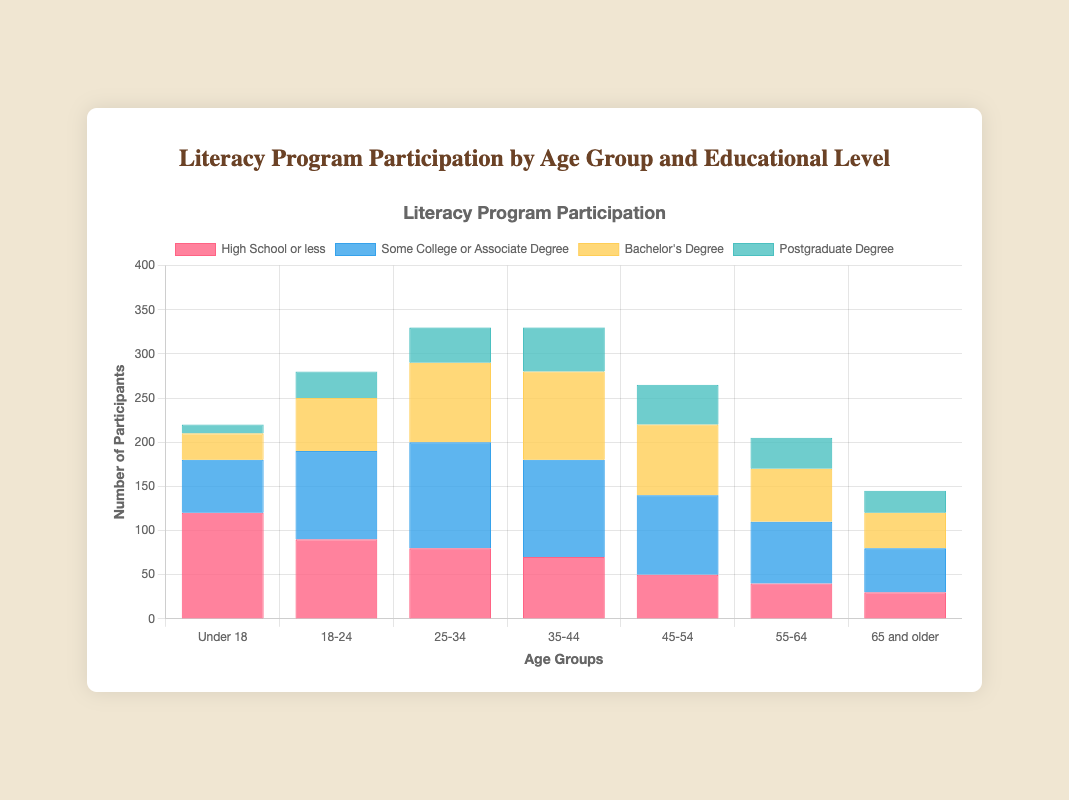What is the age group with the highest number of participants with a Bachelor's Degree? To find the age group with the highest number of participants with a Bachelor's Degree, look at the height of the bar segments representing Bachelor's Degree participants for each age group. The highest bar segment for Bachelor's Degree is for the age group 35-44.
Answer: 35-44 Which educational level has the highest participation in the age group 55-64? For the age group 55-64, compare the heights of the bars for each educational level. The highest bar segment corresponds to "Some College or Associate Degree."
Answer: Some College or Associate Degree What is the total number of participants under the age of 18? Sum the heights of all the bars for each educational level under the "Under 18" category. The values are 120 (High School or less) + 60 (Some College or Associate Degree) + 30 (Bachelor's Degree) + 10 (Postgraduate Degree), resulting in 220 total participants.
Answer: 220 Which age group has the smallest combined participation across all educational levels? Sum the heights of all the bar segments for each age group. The age group "65 and older" has the smallest combined participation: 30 (High School or less) + 50 (Some College or Associate Degree) + 40 (Bachelor's Degree) + 25 (Postgraduate Degree) = 145 participants.
Answer: 65 and older How many more participants in the age group 25-34 have some College or Associate Degree compared to those with Postgraduate Degree? Find the difference between the number of participants in the age group 25-34 with "Some College or Associate Degree" (120) and those with "Postgraduate Degree" (40). 120 - 40 = 80 more participants have some College or Associate Degree.
Answer: 80 What is the average number of participants aged 45-54 across all educational levels? Sum the number of participants aged 45-54 for each educational level and divide by the number of levels. (50 + 90 + 80 + 45) / 4 = 265 / 4 = 66.25 participants on average.
Answer: 66.25 Which educational level has higher participation in the age group 18-24: "High School or less" or "Bachelor's Degree"? Look at the heights of the bar segments for "High School or less" (90) and "Bachelor's Degree" (60) in the age group 18-24. The "High School or less" bar is higher.
Answer: High School or less What is the combined number of participants with a Bachelor's Degree and Postgraduate Degree in the age group 35-44? Add the number of participants with a Bachelor's Degree (100) to the number of participants with a Postgraduate Degree (50) in the age group 35-44. 100 + 50 = 150 participants.
Answer: 150 